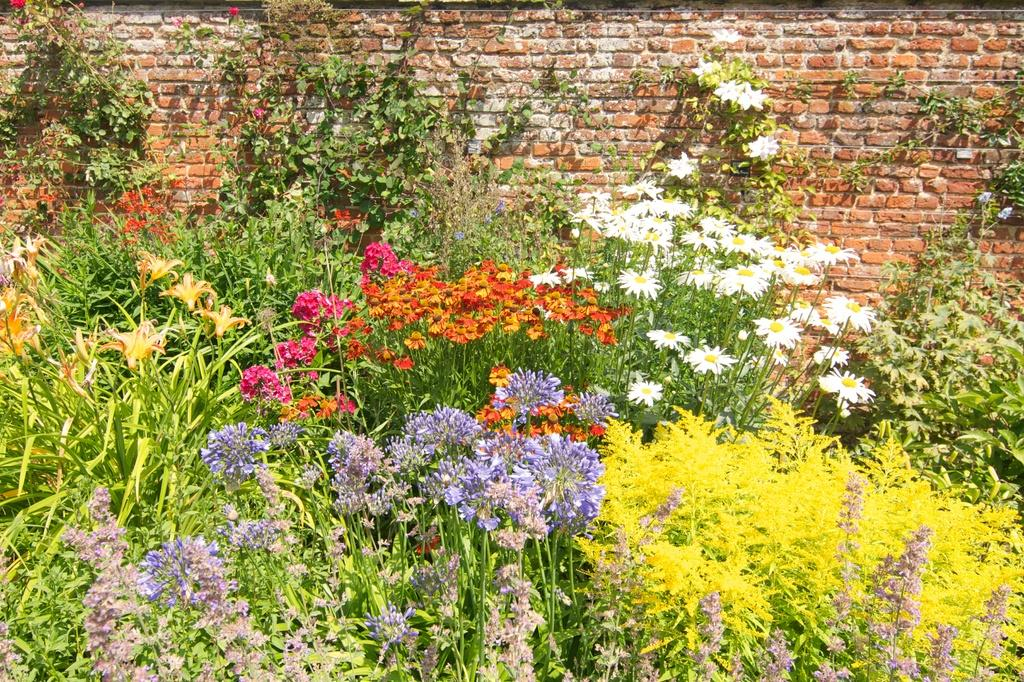What is the main subject of the image? The main subject of the image is a group of plants and flowers. Can you describe the colors of the plants and flowers? The plants and flowers have various colors, including yellow, red, pink, orange, and white. What can be seen in the background of the image? There is a wall with bricks visible in the background of the image. How many snakes are slithering among the plants and flowers in the image? There are no snakes present in the image; it features a group of plants and flowers with various colors. What theory is being tested in the image? There is no theory being tested in the image; it is a simple depiction of plants and flowers with various colors and a brick wall in the background. 